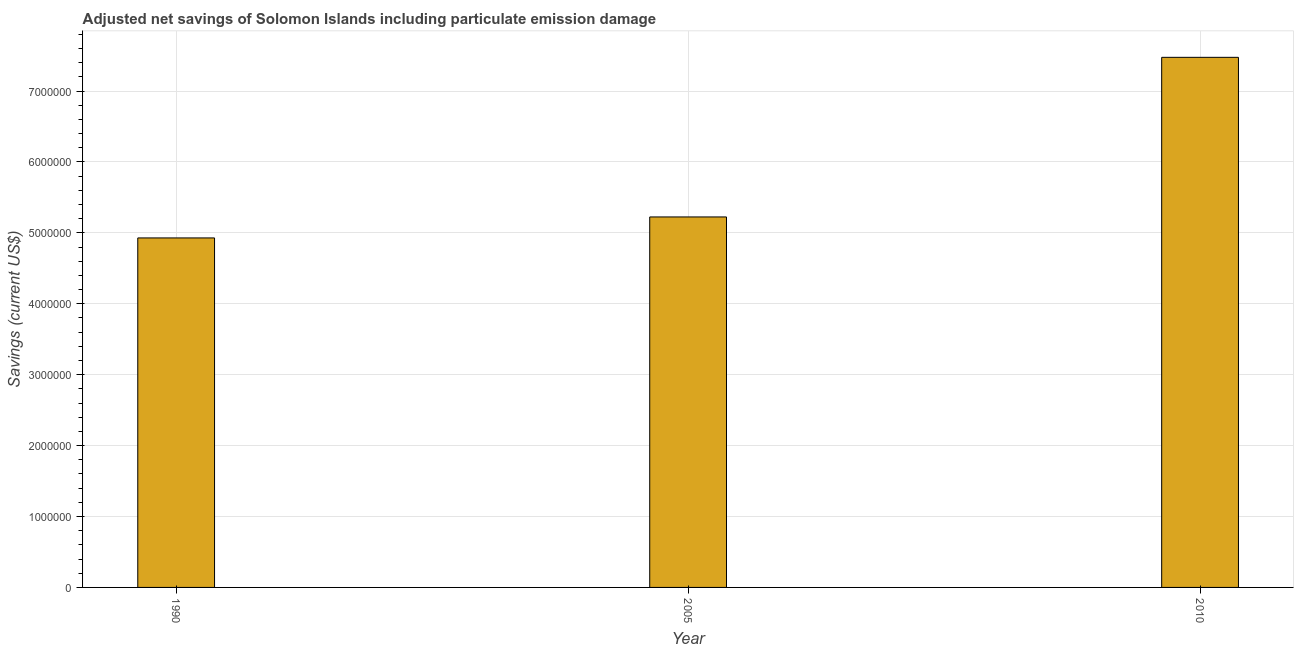Does the graph contain grids?
Your response must be concise. Yes. What is the title of the graph?
Make the answer very short. Adjusted net savings of Solomon Islands including particulate emission damage. What is the label or title of the X-axis?
Ensure brevity in your answer.  Year. What is the label or title of the Y-axis?
Keep it short and to the point. Savings (current US$). What is the adjusted net savings in 2010?
Your response must be concise. 7.48e+06. Across all years, what is the maximum adjusted net savings?
Your response must be concise. 7.48e+06. Across all years, what is the minimum adjusted net savings?
Offer a terse response. 4.93e+06. In which year was the adjusted net savings minimum?
Make the answer very short. 1990. What is the sum of the adjusted net savings?
Your response must be concise. 1.76e+07. What is the difference between the adjusted net savings in 1990 and 2010?
Your answer should be very brief. -2.55e+06. What is the average adjusted net savings per year?
Your response must be concise. 5.88e+06. What is the median adjusted net savings?
Provide a succinct answer. 5.22e+06. What is the ratio of the adjusted net savings in 1990 to that in 2010?
Ensure brevity in your answer.  0.66. Is the adjusted net savings in 2005 less than that in 2010?
Keep it short and to the point. Yes. What is the difference between the highest and the second highest adjusted net savings?
Make the answer very short. 2.25e+06. Is the sum of the adjusted net savings in 2005 and 2010 greater than the maximum adjusted net savings across all years?
Give a very brief answer. Yes. What is the difference between the highest and the lowest adjusted net savings?
Provide a succinct answer. 2.55e+06. In how many years, is the adjusted net savings greater than the average adjusted net savings taken over all years?
Keep it short and to the point. 1. How many years are there in the graph?
Your answer should be very brief. 3. What is the Savings (current US$) in 1990?
Your answer should be very brief. 4.93e+06. What is the Savings (current US$) of 2005?
Provide a succinct answer. 5.22e+06. What is the Savings (current US$) of 2010?
Offer a terse response. 7.48e+06. What is the difference between the Savings (current US$) in 1990 and 2005?
Keep it short and to the point. -2.96e+05. What is the difference between the Savings (current US$) in 1990 and 2010?
Your answer should be compact. -2.55e+06. What is the difference between the Savings (current US$) in 2005 and 2010?
Offer a very short reply. -2.25e+06. What is the ratio of the Savings (current US$) in 1990 to that in 2005?
Make the answer very short. 0.94. What is the ratio of the Savings (current US$) in 1990 to that in 2010?
Provide a succinct answer. 0.66. What is the ratio of the Savings (current US$) in 2005 to that in 2010?
Offer a very short reply. 0.7. 